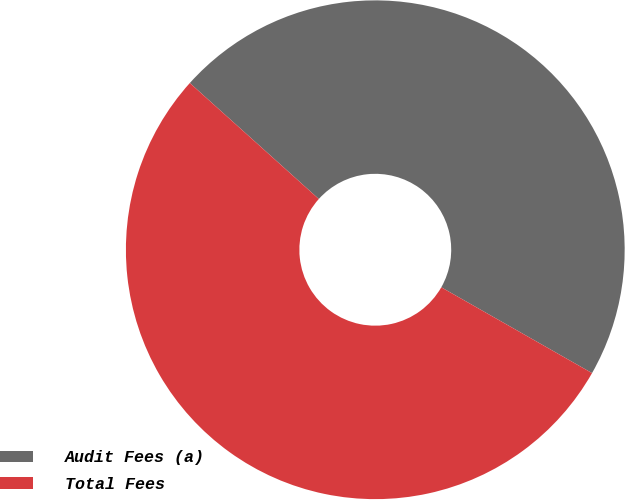Convert chart. <chart><loc_0><loc_0><loc_500><loc_500><pie_chart><fcel>Audit Fees (a)<fcel>Total Fees<nl><fcel>46.58%<fcel>53.42%<nl></chart> 